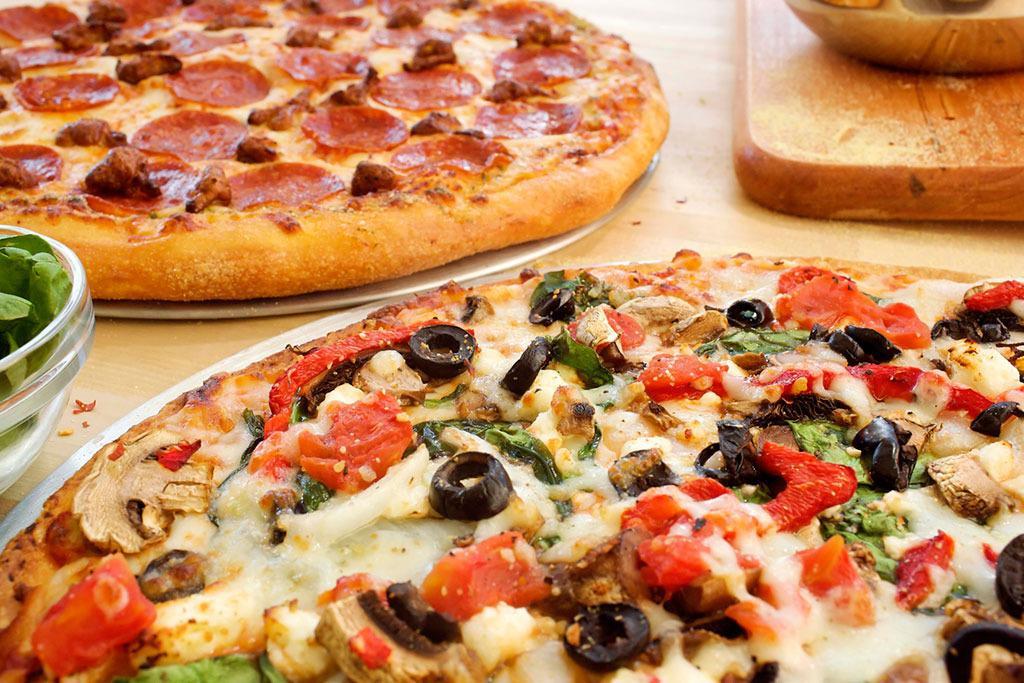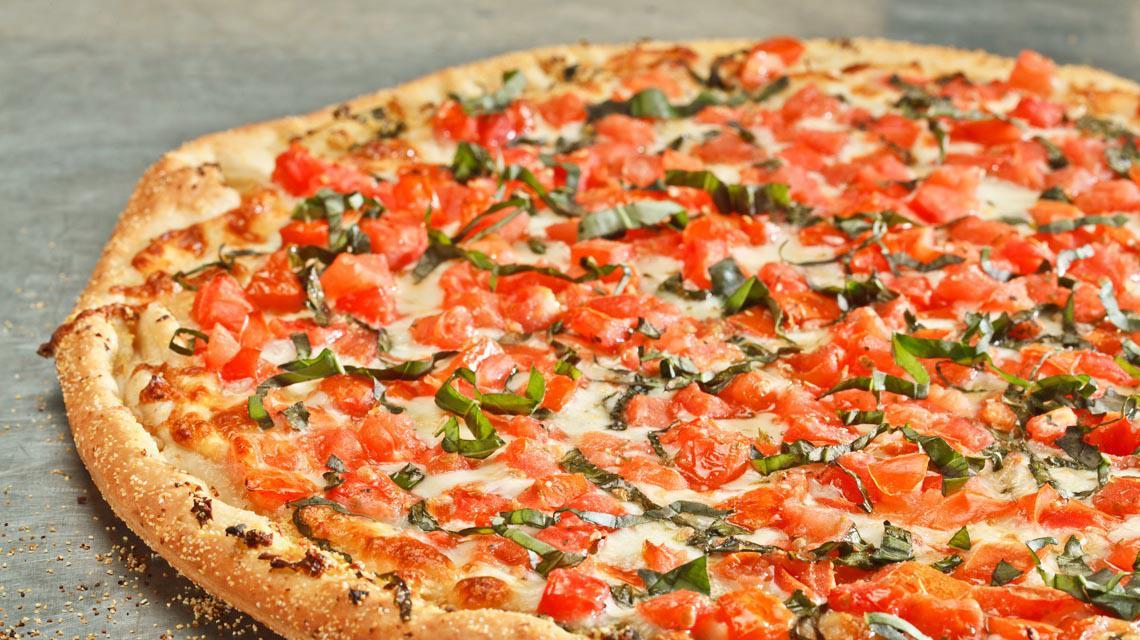The first image is the image on the left, the second image is the image on the right. For the images displayed, is the sentence "In at least one image there is a a pizza withe pepperoni on each slice that is still in the cardboard box that was delivered." factually correct? Answer yes or no. No. The first image is the image on the left, the second image is the image on the right. For the images shown, is this caption "A sliced pizza topped with pepperonis and green bits is in an open brown cardboard box in one image." true? Answer yes or no. No. 